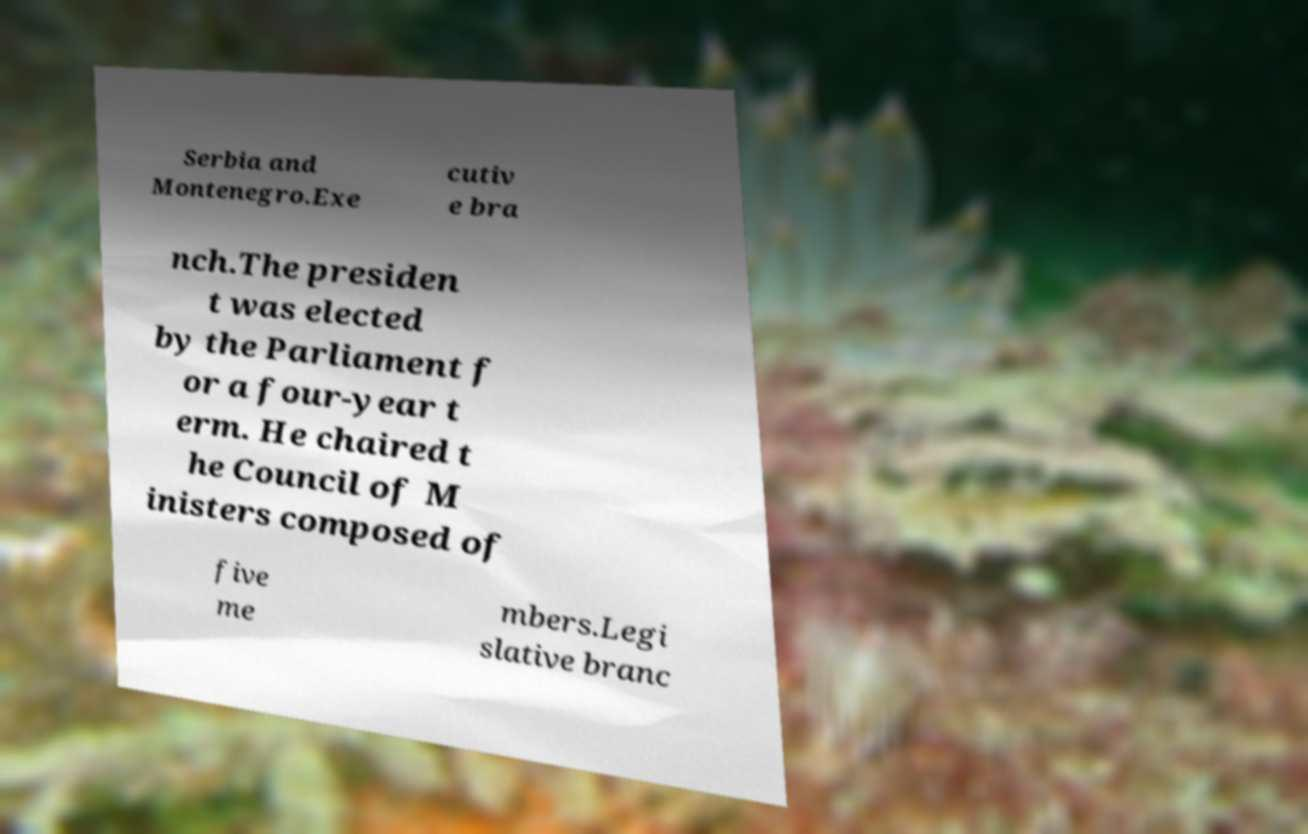Can you read and provide the text displayed in the image?This photo seems to have some interesting text. Can you extract and type it out for me? Serbia and Montenegro.Exe cutiv e bra nch.The presiden t was elected by the Parliament f or a four-year t erm. He chaired t he Council of M inisters composed of five me mbers.Legi slative branc 